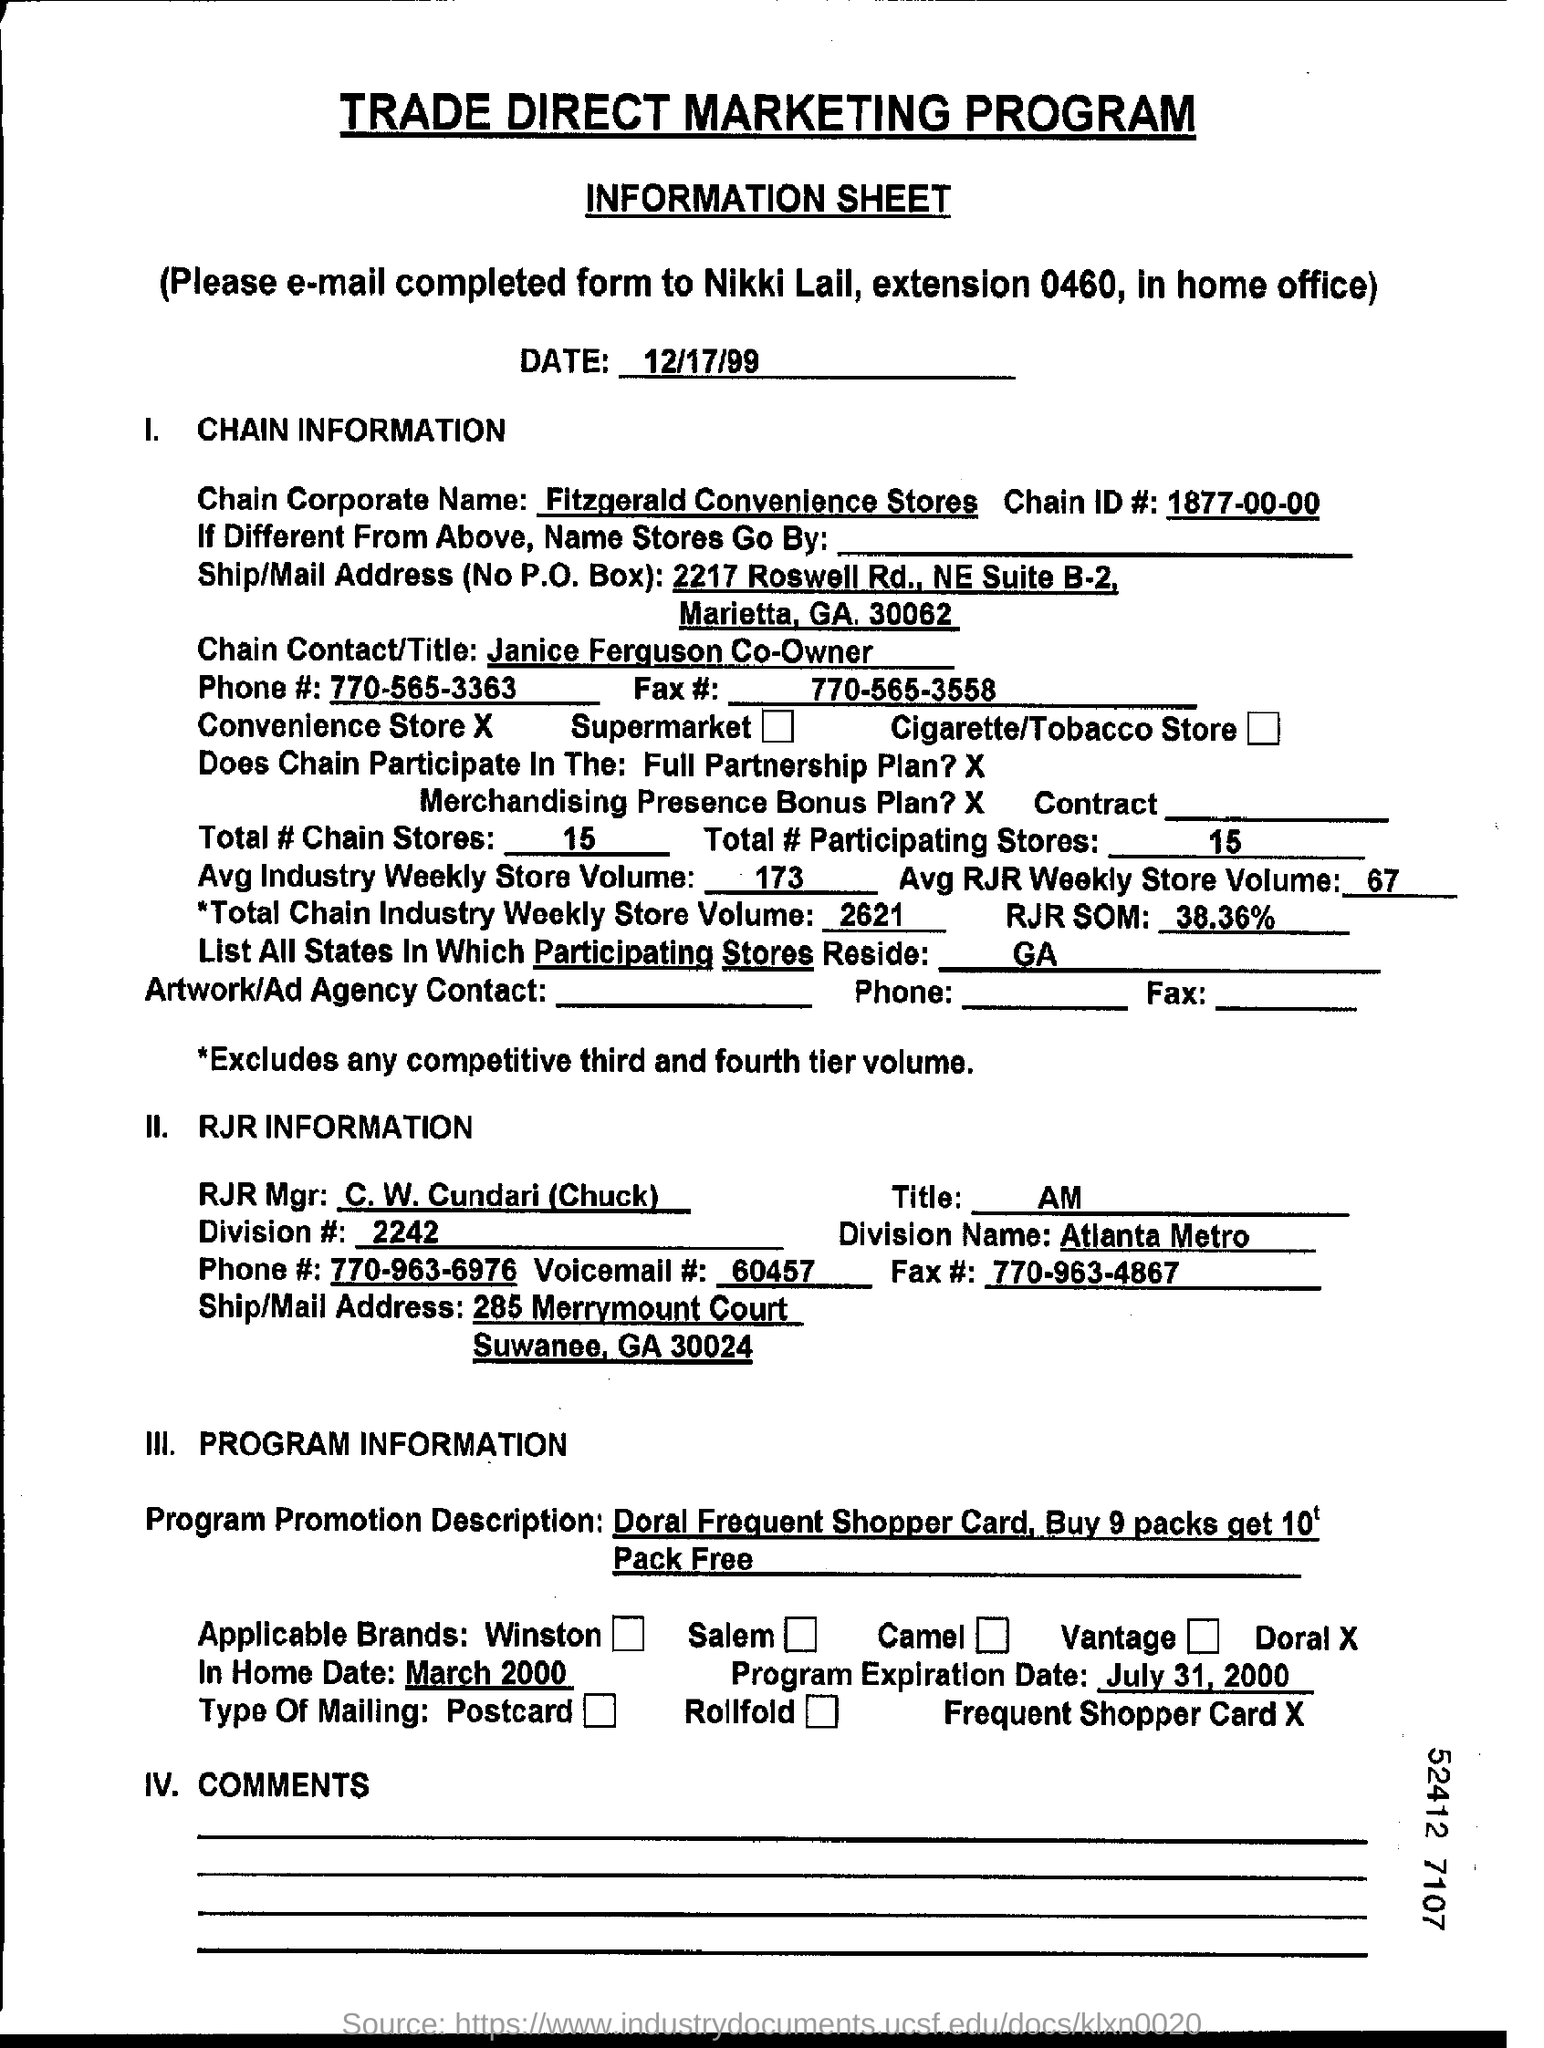Indicate a few pertinent items in this graphic. The average weekly store volume in the industry is approximately 173 units. The average weekly store volume for RJR is approximately 67. The chain corporate name mentioned in the document is Fitzgerald Convenience Stores. The program expiration date mentioned in the document is July 31, 2000. There are 15 total Chain stores. 